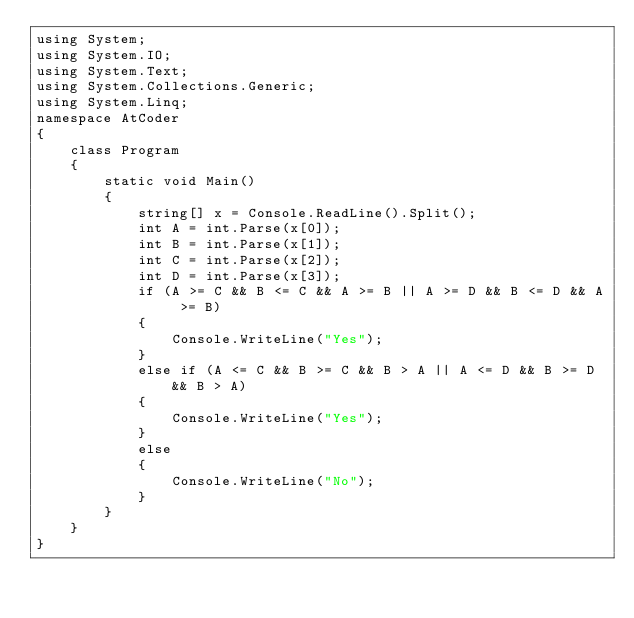Convert code to text. <code><loc_0><loc_0><loc_500><loc_500><_C#_>using System;
using System.IO;
using System.Text;
using System.Collections.Generic;
using System.Linq;
namespace AtCoder
{
    class Program
    {
        static void Main()
        {
            string[] x = Console.ReadLine().Split();
            int A = int.Parse(x[0]);
            int B = int.Parse(x[1]);
            int C = int.Parse(x[2]);
            int D = int.Parse(x[3]);
            if (A >= C && B <= C && A >= B || A >= D && B <= D && A >= B)
            {
                Console.WriteLine("Yes");
            }
            else if (A <= C && B >= C && B > A || A <= D && B >= D && B > A)
            {
                Console.WriteLine("Yes");
            }
            else
            {
                Console.WriteLine("No");
            }
        }
    }
}</code> 